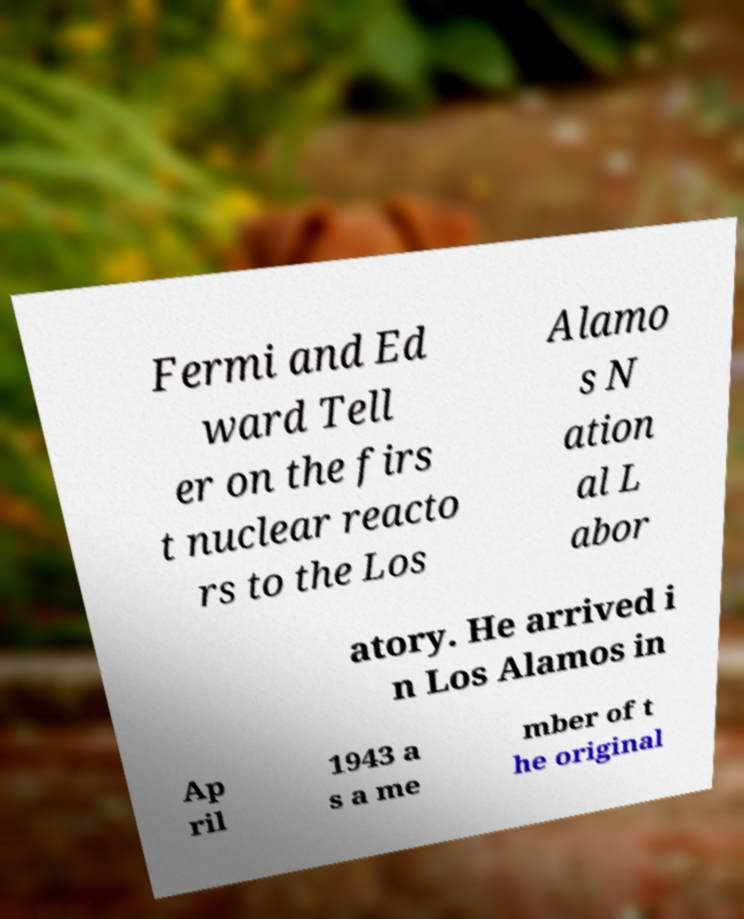For documentation purposes, I need the text within this image transcribed. Could you provide that? Fermi and Ed ward Tell er on the firs t nuclear reacto rs to the Los Alamo s N ation al L abor atory. He arrived i n Los Alamos in Ap ril 1943 a s a me mber of t he original 